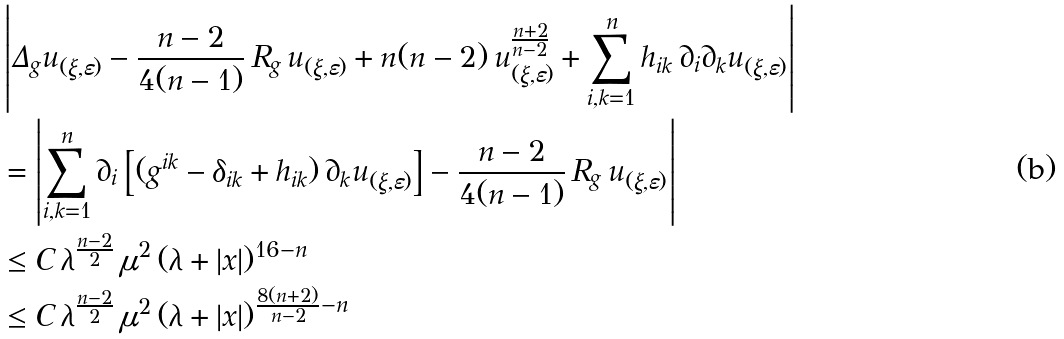Convert formula to latex. <formula><loc_0><loc_0><loc_500><loc_500>& \left | \Delta _ { g } u _ { ( \xi , \varepsilon ) } - \frac { n - 2 } { 4 ( n - 1 ) } \, R _ { g } \, u _ { ( \xi , \varepsilon ) } + n ( n - 2 ) \, u _ { ( \xi , \varepsilon ) } ^ { \frac { n + 2 } { n - 2 } } + \sum _ { i , k = 1 } ^ { n } h _ { i k } \, \partial _ { i } \partial _ { k } u _ { ( \xi , \varepsilon ) } \right | \\ & = \left | \sum _ { i , k = 1 } ^ { n } \partial _ { i } \left [ ( g ^ { i k } - \delta _ { i k } + h _ { i k } ) \, \partial _ { k } u _ { ( \xi , \varepsilon ) } \right ] - \frac { n - 2 } { 4 ( n - 1 ) } \, R _ { g } \, u _ { ( \xi , \varepsilon ) } \right | \\ & \leq C \, \lambda ^ { \frac { n - 2 } { 2 } } \, \mu ^ { 2 } \, ( \lambda + | x | ) ^ { 1 6 - n } \\ & \leq C \, \lambda ^ { \frac { n - 2 } { 2 } } \, \mu ^ { 2 } \, ( \lambda + | x | ) ^ { \frac { 8 ( n + 2 ) } { n - 2 } - n }</formula> 